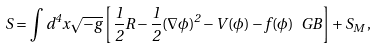Convert formula to latex. <formula><loc_0><loc_0><loc_500><loc_500>S = \int d ^ { 4 } x \sqrt { - g } \left [ \frac { 1 } { 2 } R - \frac { 1 } { 2 } ( \nabla \phi ) ^ { 2 } - V ( \phi ) - f ( \phi ) \, \ G B \right ] + S _ { M } \, ,</formula> 